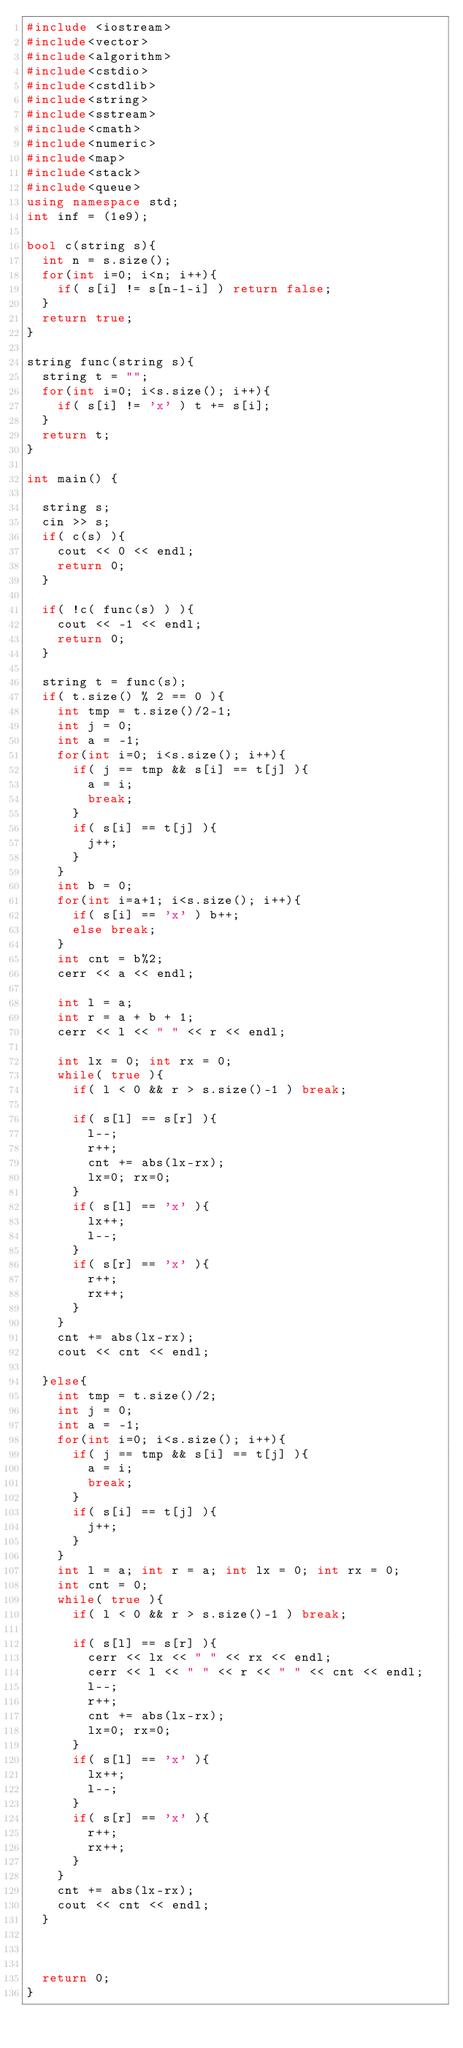Convert code to text. <code><loc_0><loc_0><loc_500><loc_500><_C++_>#include <iostream>
#include<vector>
#include<algorithm>
#include<cstdio>
#include<cstdlib>
#include<string>
#include<sstream>
#include<cmath>
#include<numeric>
#include<map>
#include<stack>
#include<queue>
using namespace std;
int inf = (1e9);

bool c(string s){
  int n = s.size();
  for(int i=0; i<n; i++){
    if( s[i] != s[n-1-i] ) return false;
  }
  return true;
}

string func(string s){
  string t = "";
  for(int i=0; i<s.size(); i++){
    if( s[i] != 'x' ) t += s[i];
  }
  return t;
}

int main() {

  string s;
  cin >> s;
  if( c(s) ){
    cout << 0 << endl;
    return 0;
  }

  if( !c( func(s) ) ){
    cout << -1 << endl;
    return 0;
  }

  string t = func(s);
  if( t.size() % 2 == 0 ){
    int tmp = t.size()/2-1;
    int j = 0;
    int a = -1;
    for(int i=0; i<s.size(); i++){
      if( j == tmp && s[i] == t[j] ){
        a = i;
        break;
      }
      if( s[i] == t[j] ){
        j++;
      }
    }
    int b = 0;
    for(int i=a+1; i<s.size(); i++){
      if( s[i] == 'x' ) b++;
      else break;
    }
    int cnt = b%2;
    cerr << a << endl;

    int l = a;
    int r = a + b + 1;
    cerr << l << " " << r << endl;

    int lx = 0; int rx = 0;
    while( true ){
      if( l < 0 && r > s.size()-1 ) break;

      if( s[l] == s[r] ){
        l--;
        r++;
        cnt += abs(lx-rx);
        lx=0; rx=0;
      }
      if( s[l] == 'x' ){
        lx++;
        l--;
      }
      if( s[r] == 'x' ){
        r++;
        rx++;
      }
    }
    cnt += abs(lx-rx);
    cout << cnt << endl;

  }else{
    int tmp = t.size()/2;
    int j = 0;
    int a = -1;
    for(int i=0; i<s.size(); i++){
      if( j == tmp && s[i] == t[j] ){
        a = i;
        break;
      }
      if( s[i] == t[j] ){
        j++;
      }
    }
    int l = a; int r = a; int lx = 0; int rx = 0;
    int cnt = 0;
    while( true ){
      if( l < 0 && r > s.size()-1 ) break;

      if( s[l] == s[r] ){
        cerr << lx << " " << rx << endl;
        cerr << l << " " << r << " " << cnt << endl;
        l--;
        r++;
        cnt += abs(lx-rx);
        lx=0; rx=0;
      }
      if( s[l] == 'x' ){
        lx++;
        l--;
      }
      if( s[r] == 'x' ){
        r++;
        rx++;
      }
    }
    cnt += abs(lx-rx);
    cout << cnt << endl;
  }



  return 0;
}
</code> 